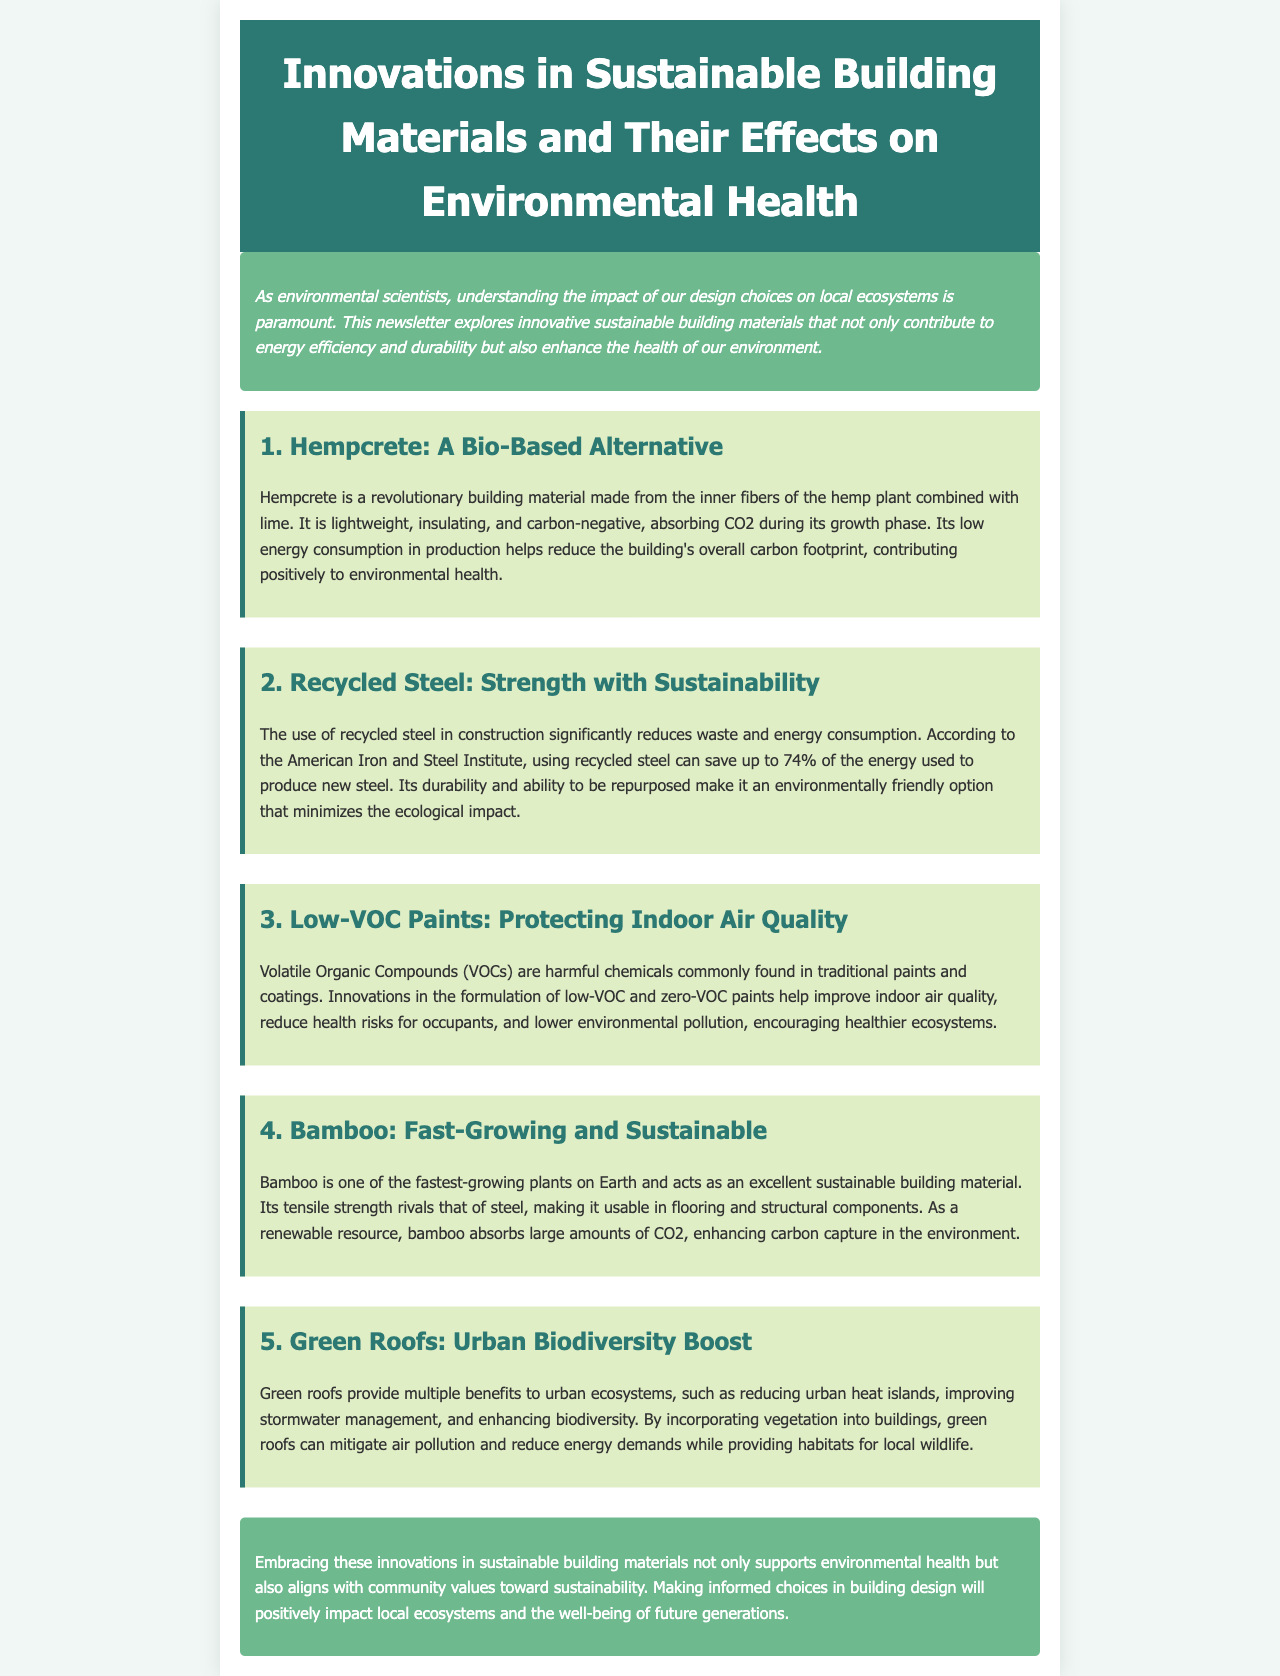What is Hempcrete made from? Hempcrete is made from the inner fibers of the hemp plant combined with lime.
Answer: inner fibers of the hemp plant combined with lime What percentage of energy can be saved by using recycled steel? According to the American Iron and Steel Institute, using recycled steel can save up to 74% of the energy used to produce new steel.
Answer: 74% What are the benefits of low-VOC paints? Innovations in the formulation of low-VOC and zero-VOC paints help improve indoor air quality, reduce health risks for occupants, and lower environmental pollution.
Answer: improve indoor air quality, reduce health risks, lower environmental pollution What is bamboo's tensile strength comparable to? Bamboo's tensile strength rivals that of steel.
Answer: steel What ecological benefit do green roofs provide? Green roofs provide multiple benefits to urban ecosystems, such as reducing urban heat islands, improving stormwater management, and enhancing biodiversity.
Answer: reducing urban heat islands, improving stormwater management, enhancing biodiversity 